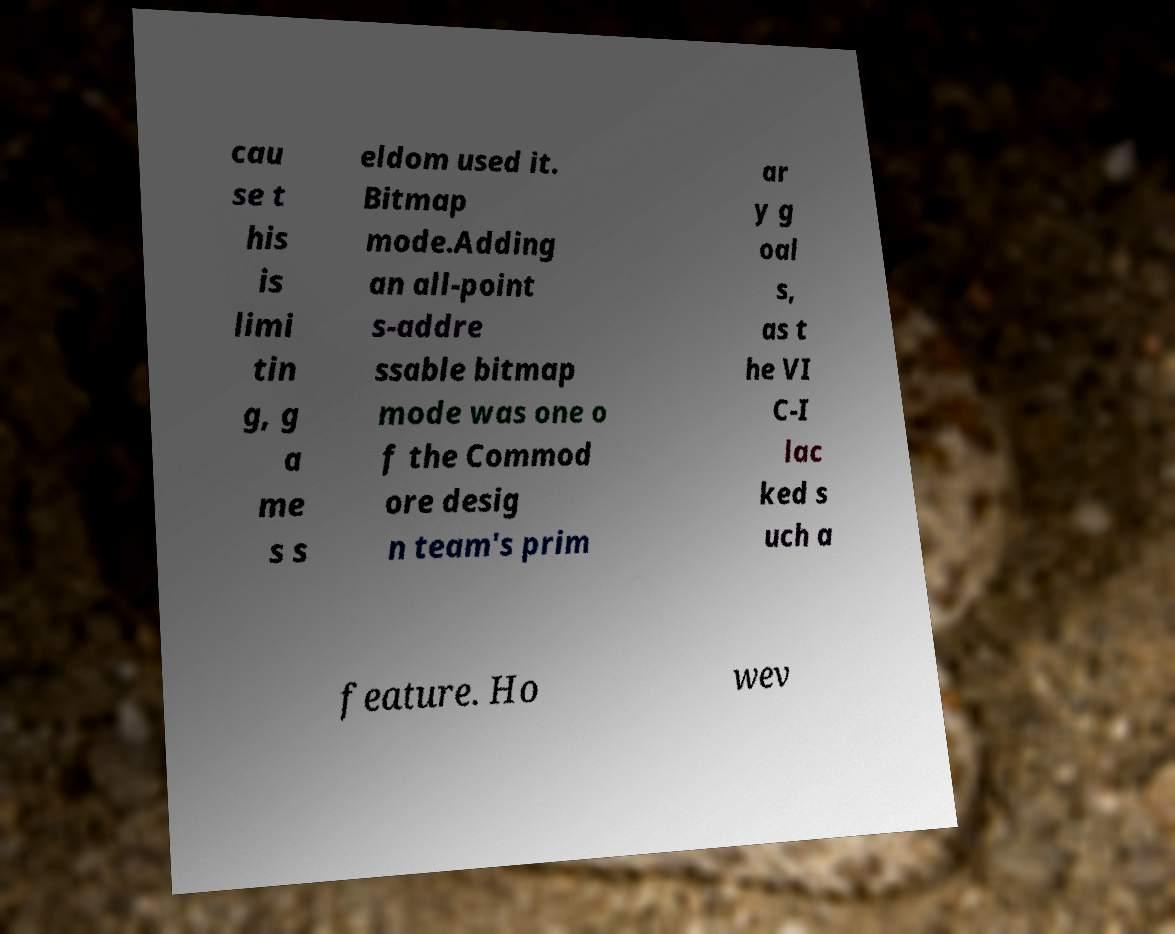Could you assist in decoding the text presented in this image and type it out clearly? cau se t his is limi tin g, g a me s s eldom used it. Bitmap mode.Adding an all-point s-addre ssable bitmap mode was one o f the Commod ore desig n team's prim ar y g oal s, as t he VI C-I lac ked s uch a feature. Ho wev 